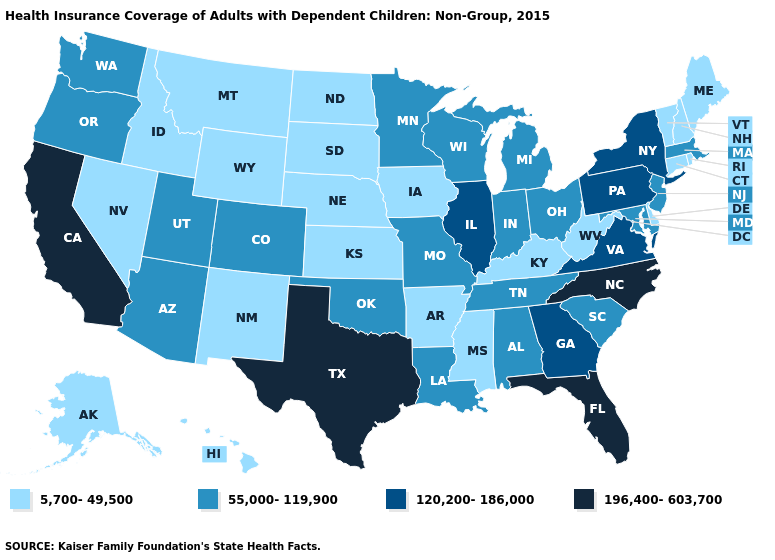Does North Carolina have the highest value in the USA?
Quick response, please. Yes. What is the value of Pennsylvania?
Be succinct. 120,200-186,000. Name the states that have a value in the range 196,400-603,700?
Concise answer only. California, Florida, North Carolina, Texas. Among the states that border Connecticut , which have the lowest value?
Quick response, please. Rhode Island. What is the value of Maine?
Keep it brief. 5,700-49,500. Which states have the highest value in the USA?
Write a very short answer. California, Florida, North Carolina, Texas. Does Oklahoma have the lowest value in the USA?
Keep it brief. No. Does the first symbol in the legend represent the smallest category?
Short answer required. Yes. Name the states that have a value in the range 120,200-186,000?
Short answer required. Georgia, Illinois, New York, Pennsylvania, Virginia. How many symbols are there in the legend?
Give a very brief answer. 4. Does Missouri have the lowest value in the MidWest?
Write a very short answer. No. How many symbols are there in the legend?
Answer briefly. 4. What is the value of Maryland?
Concise answer only. 55,000-119,900. What is the lowest value in the South?
Give a very brief answer. 5,700-49,500. Name the states that have a value in the range 196,400-603,700?
Answer briefly. California, Florida, North Carolina, Texas. 